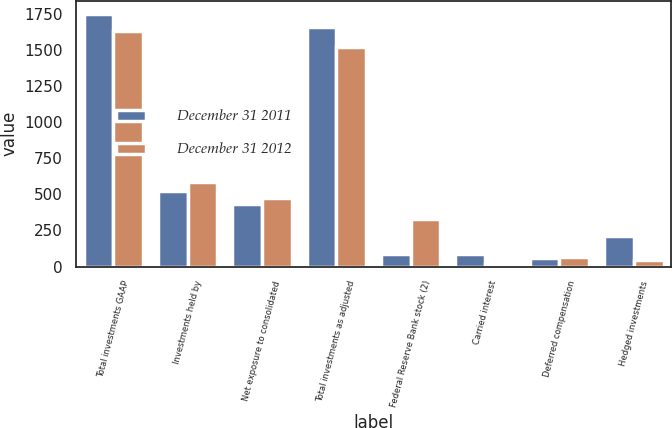Convert chart. <chart><loc_0><loc_0><loc_500><loc_500><stacked_bar_chart><ecel><fcel>Total investments GAAP<fcel>Investments held by<fcel>Net exposure to consolidated<fcel>Total investments as adjusted<fcel>Federal Reserve Bank stock (2)<fcel>Carried interest<fcel>Deferred compensation<fcel>Hedged investments<nl><fcel>December 31 2011<fcel>1750<fcel>524<fcel>430<fcel>1656<fcel>89<fcel>85<fcel>62<fcel>209<nl><fcel>December 31 2012<fcel>1631<fcel>587<fcel>475<fcel>1519<fcel>328<fcel>21<fcel>65<fcel>43<nl></chart> 